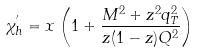Convert formula to latex. <formula><loc_0><loc_0><loc_500><loc_500>\chi ^ { ^ { \prime } } _ { h } = x \left ( 1 + \frac { M ^ { 2 } + z ^ { 2 } q _ { T } ^ { 2 } } { z ( 1 - z ) Q ^ { 2 } } \right )</formula> 